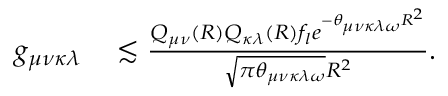Convert formula to latex. <formula><loc_0><loc_0><loc_500><loc_500>\begin{array} { r l } { g _ { \mu \nu \kappa \lambda } } & \lesssim \frac { Q _ { \mu \nu } ( R ) Q _ { \kappa \lambda } ( R ) f _ { l } e ^ { - \theta _ { \mu \nu \kappa \lambda \omega } R ^ { 2 } } } { \sqrt { \pi \theta _ { \mu \nu \kappa \lambda \omega } } R ^ { 2 } } . } \end{array}</formula> 